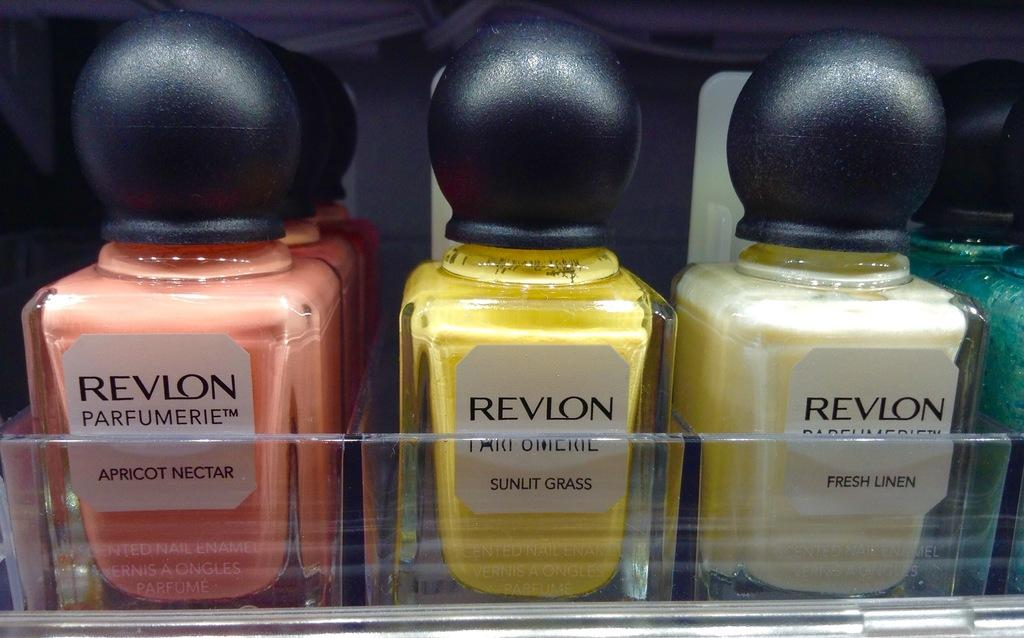<image>
Describe the image concisely. Three bottles of Revlon sit next to each other with one being Apricot Nectar, Sunut Grass, and Fresh Linen. 